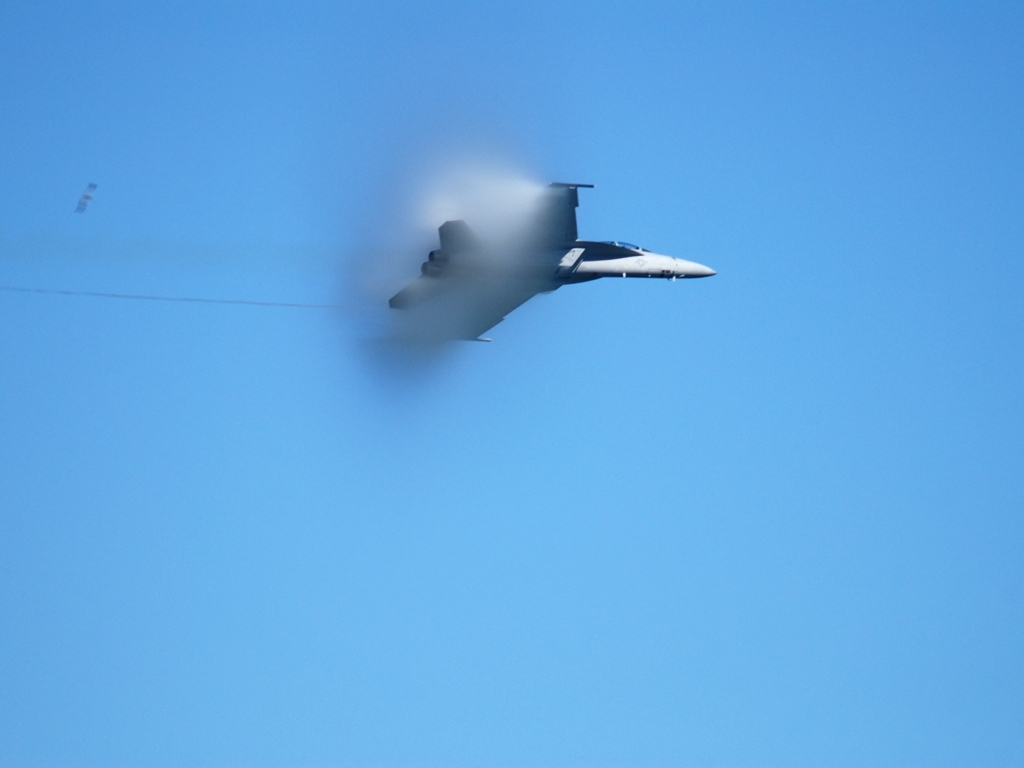What is creating the haze around the jet? The haze around the jet is likely caused by condensation of water droplets due to the rapid compression and decompression of air as the jet approaches the speed of sound, creating a visible vapor cone. This is a physical phenomenon known as a 'sonic boom' precursor. 